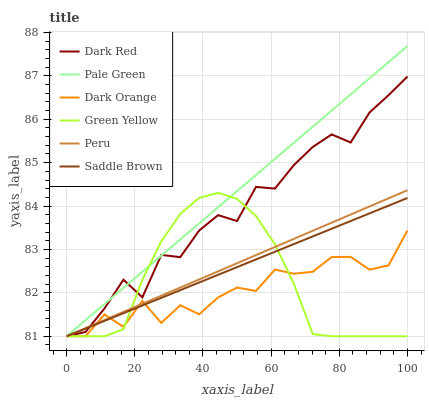Does Dark Orange have the minimum area under the curve?
Answer yes or no. Yes. Does Dark Red have the minimum area under the curve?
Answer yes or no. No. Does Dark Red have the maximum area under the curve?
Answer yes or no. No. Is Dark Red the smoothest?
Answer yes or no. No. Is Pale Green the roughest?
Answer yes or no. No. Does Dark Red have the highest value?
Answer yes or no. No. 